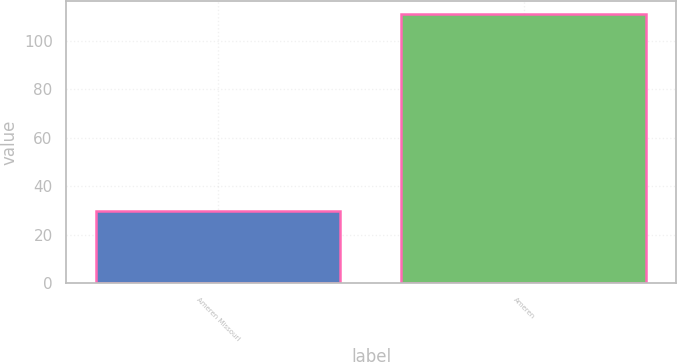Convert chart. <chart><loc_0><loc_0><loc_500><loc_500><bar_chart><fcel>Ameren Missouri<fcel>Ameren<nl><fcel>30<fcel>111<nl></chart> 